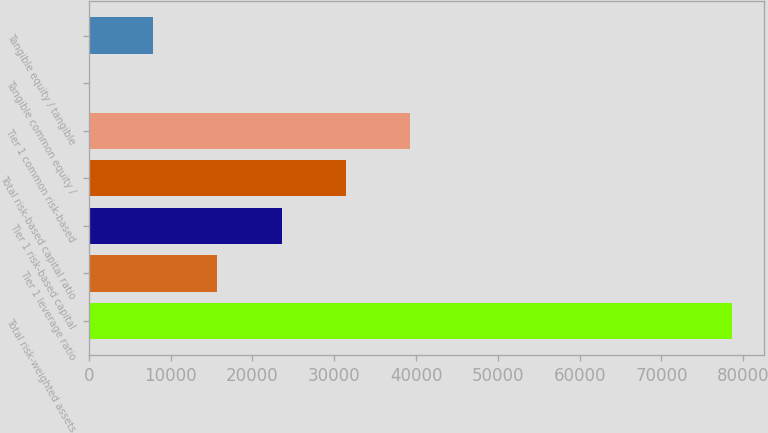<chart> <loc_0><loc_0><loc_500><loc_500><bar_chart><fcel>Total risk-weighted assets<fcel>Tier 1 leverage ratio<fcel>Tier 1 risk-based capital<fcel>Total risk-based capital ratio<fcel>Tier 1 common risk-based<fcel>Tangible common equity /<fcel>Tangible equity / tangible<nl><fcel>78631<fcel>15732.1<fcel>23594.5<fcel>31456.9<fcel>39319.2<fcel>7.42<fcel>7869.78<nl></chart> 